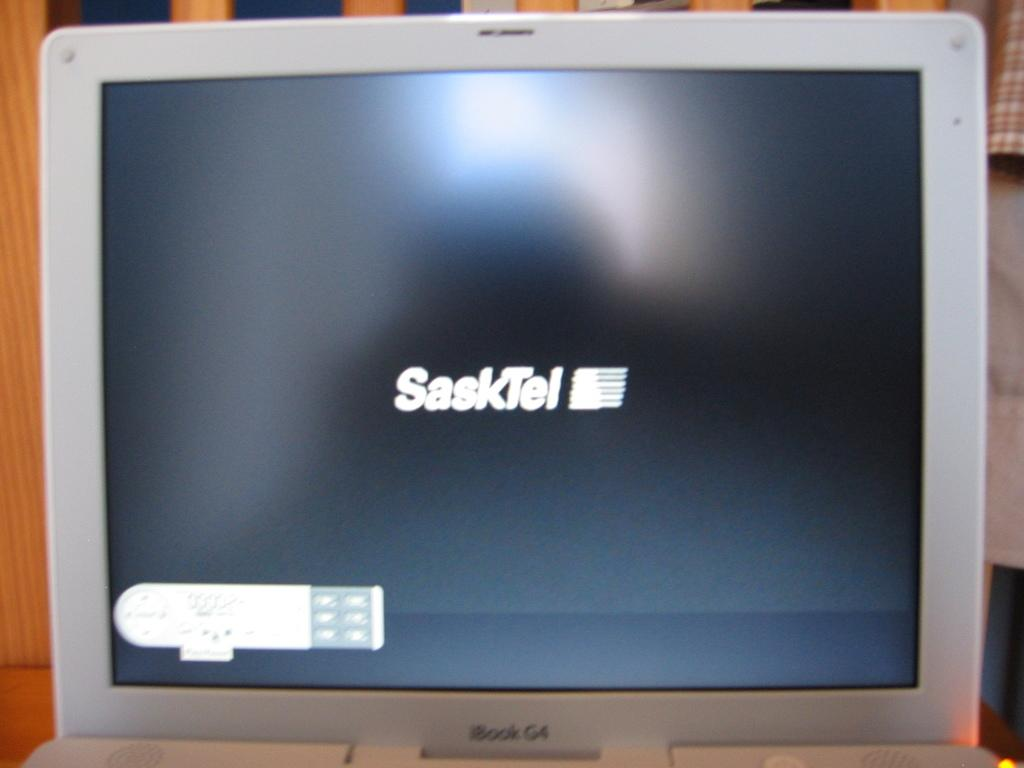<image>
Render a clear and concise summary of the photo. an iBook G4 monitor with SaskTel icon start up screen 